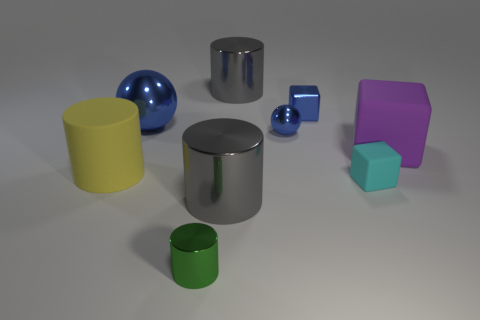Is the material of the big gray cylinder that is behind the small blue cube the same as the large ball?
Your response must be concise. Yes. Are there any other things that have the same size as the green thing?
Your answer should be compact. Yes. What material is the tiny block that is behind the large matte object that is on the right side of the small matte block made of?
Provide a short and direct response. Metal. Is the number of large objects in front of the small cyan thing greater than the number of green shiny things to the right of the rubber cylinder?
Keep it short and to the point. No. What is the size of the cyan block?
Give a very brief answer. Small. Is the color of the large matte thing on the right side of the metal cube the same as the small cylinder?
Offer a terse response. No. Is there anything else that is the same shape as the tiny green shiny thing?
Make the answer very short. Yes. There is a big gray shiny object that is in front of the big purple thing; is there a blue object that is on the left side of it?
Provide a short and direct response. Yes. Are there fewer large shiny balls in front of the purple thing than tiny green things that are behind the green thing?
Make the answer very short. No. How big is the green cylinder that is to the left of the large gray cylinder behind the small cube in front of the purple matte cube?
Make the answer very short. Small. 